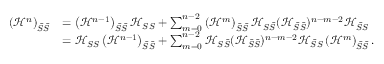<formula> <loc_0><loc_0><loc_500><loc_500>\begin{array} { r l } { \left ( \mathcal { H } ^ { n } \right ) _ { \bar { S } \bar { S } } } & { = \left ( \mathcal { H } ^ { n - 1 } \right ) _ { \bar { S } \bar { S } } \mathcal { H } _ { S S } + \sum _ { m = 0 } ^ { n - 2 } \left ( \mathcal { H } ^ { m } \right ) _ { \bar { S } \bar { S } } \mathcal { H } _ { S \bar { S } } ( \mathcal { H } _ { \bar { S } \bar { S } } ) ^ { n - m - 2 } \mathcal { H } _ { \bar { S } S } } \\ & { = \mathcal { H } _ { S S } \left ( \mathcal { H } ^ { n - 1 } \right ) _ { \bar { S } \bar { S } } + \sum _ { m = 0 } ^ { n - 2 } \mathcal { H } _ { S \bar { S } } ( \mathcal { H } _ { \bar { S } \bar { S } } ) ^ { n - m - 2 } \mathcal { H } _ { \bar { S } S } \left ( \mathcal { H } ^ { m } \right ) _ { \bar { S } \bar { S } } . } \end{array}</formula> 